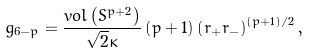<formula> <loc_0><loc_0><loc_500><loc_500>g _ { 6 - p } = \frac { v o l \left ( S ^ { p + 2 } \right ) } { \sqrt { 2 } \kappa } \left ( p + 1 \right ) \left ( r _ { + } r _ { - } \right ) ^ { \left ( p + 1 \right ) / 2 } ,</formula> 